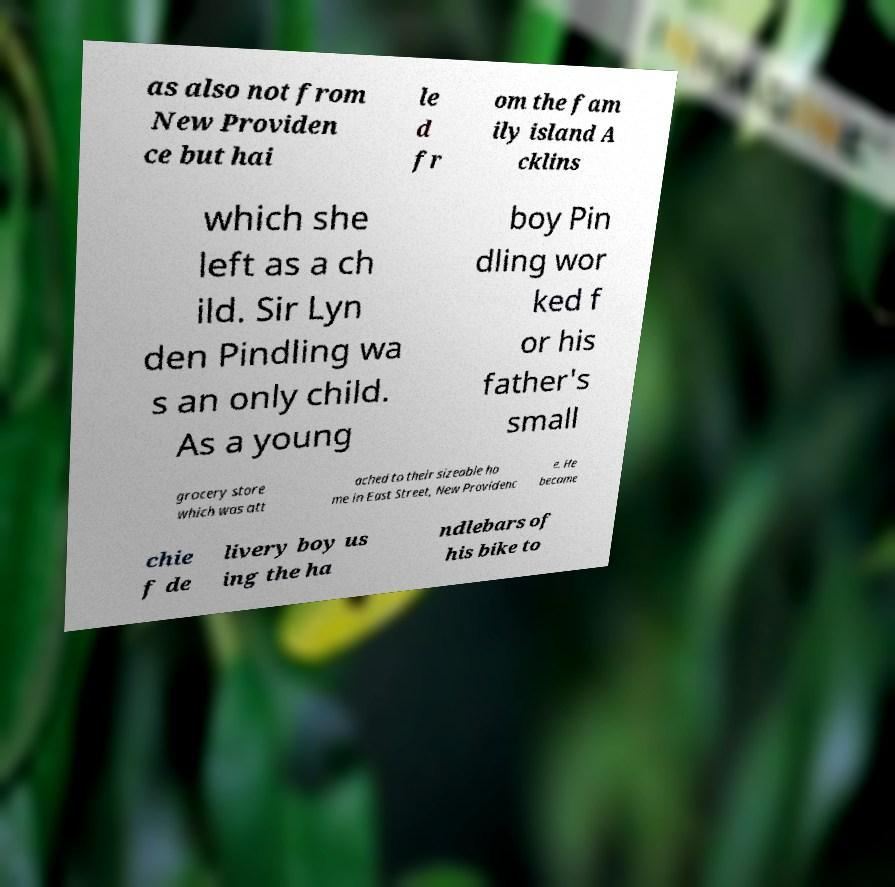Please read and relay the text visible in this image. What does it say? as also not from New Providen ce but hai le d fr om the fam ily island A cklins which she left as a ch ild. Sir Lyn den Pindling wa s an only child. As a young boy Pin dling wor ked f or his father's small grocery store which was att ached to their sizeable ho me in East Street, New Providenc e. He became chie f de livery boy us ing the ha ndlebars of his bike to 